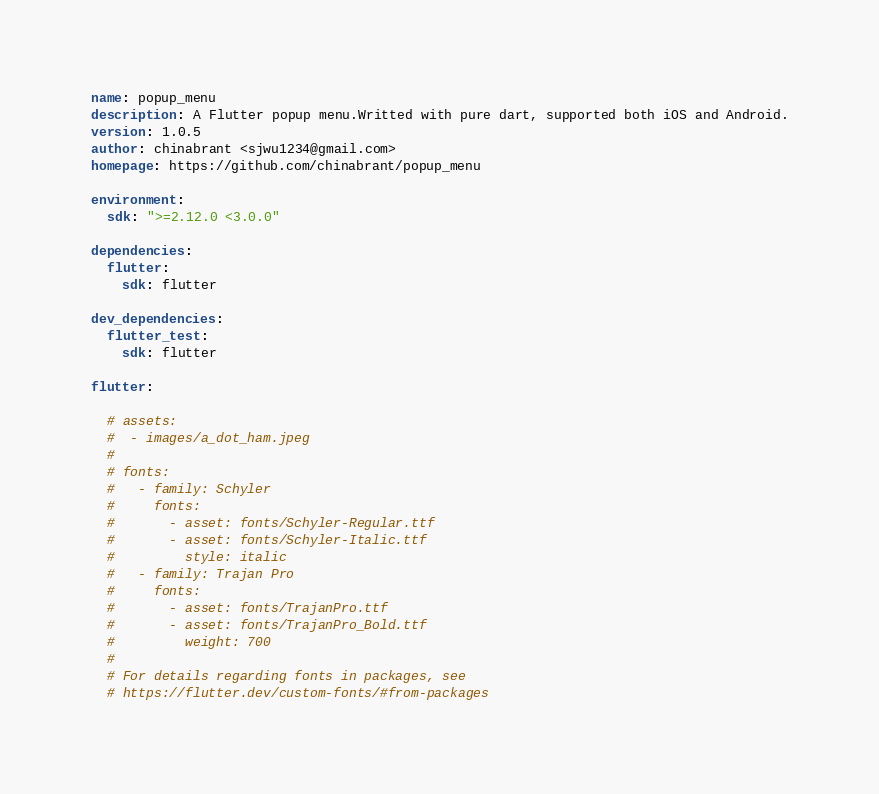<code> <loc_0><loc_0><loc_500><loc_500><_YAML_>name: popup_menu
description: A Flutter popup menu.Writted with pure dart, supported both iOS and Android.
version: 1.0.5
author: chinabrant <sjwu1234@gmail.com>
homepage: https://github.com/chinabrant/popup_menu

environment:
  sdk: ">=2.12.0 <3.0.0"

dependencies:
  flutter:
    sdk: flutter

dev_dependencies:
  flutter_test:
    sdk: flutter

flutter:

  # assets:
  #  - images/a_dot_ham.jpeg
  #
  # fonts:
  #   - family: Schyler
  #     fonts:
  #       - asset: fonts/Schyler-Regular.ttf
  #       - asset: fonts/Schyler-Italic.ttf
  #         style: italic
  #   - family: Trajan Pro
  #     fonts:
  #       - asset: fonts/TrajanPro.ttf
  #       - asset: fonts/TrajanPro_Bold.ttf
  #         weight: 700
  #
  # For details regarding fonts in packages, see
  # https://flutter.dev/custom-fonts/#from-packages
</code> 